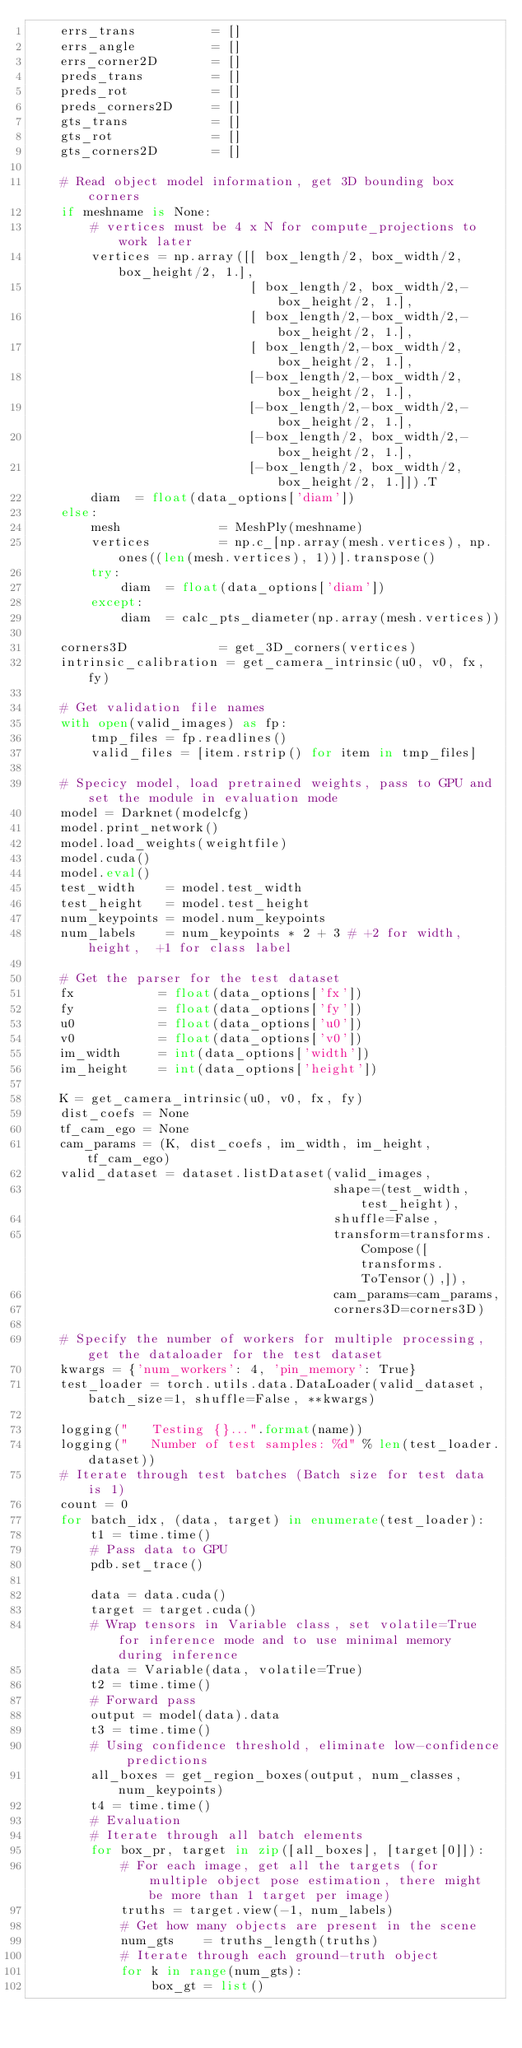<code> <loc_0><loc_0><loc_500><loc_500><_Python_>    errs_trans          = []
    errs_angle          = []
    errs_corner2D       = []
    preds_trans         = []
    preds_rot           = []
    preds_corners2D     = []
    gts_trans           = []
    gts_rot             = []
    gts_corners2D       = []

    # Read object model information, get 3D bounding box corners
    if meshname is None:
        # vertices must be 4 x N for compute_projections to work later
        vertices = np.array([[ box_length/2, box_width/2, box_height/2, 1.],
                             [ box_length/2, box_width/2,-box_height/2, 1.],
                             [ box_length/2,-box_width/2,-box_height/2, 1.],
                             [ box_length/2,-box_width/2, box_height/2, 1.],
                             [-box_length/2,-box_width/2, box_height/2, 1.],
                             [-box_length/2,-box_width/2,-box_height/2, 1.],
                             [-box_length/2, box_width/2,-box_height/2, 1.],
                             [-box_length/2, box_width/2, box_height/2, 1.]]).T
        diam  = float(data_options['diam'])
    else:
        mesh             = MeshPly(meshname)
        vertices         = np.c_[np.array(mesh.vertices), np.ones((len(mesh.vertices), 1))].transpose()
        try:
            diam  = float(data_options['diam'])
        except:
            diam  = calc_pts_diameter(np.array(mesh.vertices))
        
    corners3D            = get_3D_corners(vertices)
    intrinsic_calibration = get_camera_intrinsic(u0, v0, fx, fy)

    # Get validation file names
    with open(valid_images) as fp:
        tmp_files = fp.readlines()
        valid_files = [item.rstrip() for item in tmp_files]
    
    # Specicy model, load pretrained weights, pass to GPU and set the module in evaluation mode
    model = Darknet(modelcfg)
    model.print_network()
    model.load_weights(weightfile)
    model.cuda()
    model.eval()
    test_width    = model.test_width
    test_height   = model.test_height
    num_keypoints = model.num_keypoints 
    num_labels    = num_keypoints * 2 + 3 # +2 for width, height,  +1 for class label

    # Get the parser for the test dataset
    fx           = float(data_options['fx'])
    fy           = float(data_options['fy'])
    u0           = float(data_options['u0'])
    v0           = float(data_options['v0'])
    im_width     = int(data_options['width'])
    im_height    = int(data_options['height'])

    K = get_camera_intrinsic(u0, v0, fx, fy)
    dist_coefs = None
    tf_cam_ego = None
    cam_params = (K, dist_coefs, im_width, im_height, tf_cam_ego)
    valid_dataset = dataset.listDataset(valid_images, 
                                        shape=(test_width, test_height),
                                        shuffle=False,
                                        transform=transforms.Compose([transforms.ToTensor(),]),
                                        cam_params=cam_params,
                                        corners3D=corners3D)

    # Specify the number of workers for multiple processing, get the dataloader for the test dataset
    kwargs = {'num_workers': 4, 'pin_memory': True}
    test_loader = torch.utils.data.DataLoader(valid_dataset, batch_size=1, shuffle=False, **kwargs) 

    logging("   Testing {}...".format(name))
    logging("   Number of test samples: %d" % len(test_loader.dataset))
    # Iterate through test batches (Batch size for test data is 1)
    count = 0
    for batch_idx, (data, target) in enumerate(test_loader):
        t1 = time.time()
        # Pass data to GPU
        pdb.set_trace()

        data = data.cuda()
        target = target.cuda()
        # Wrap tensors in Variable class, set volatile=True for inference mode and to use minimal memory during inference
        data = Variable(data, volatile=True)
        t2 = time.time()
        # Forward pass
        output = model(data).data  
        t3 = time.time()
        # Using confidence threshold, eliminate low-confidence predictions
        all_boxes = get_region_boxes(output, num_classes, num_keypoints)        
        t4 = time.time()
        # Evaluation
        # Iterate through all batch elements
        for box_pr, target in zip([all_boxes], [target[0]]):
            # For each image, get all the targets (for multiple object pose estimation, there might be more than 1 target per image)
            truths = target.view(-1, num_labels)
            # Get how many objects are present in the scene
            num_gts    = truths_length(truths)
            # Iterate through each ground-truth object
            for k in range(num_gts):
                box_gt = list()</code> 